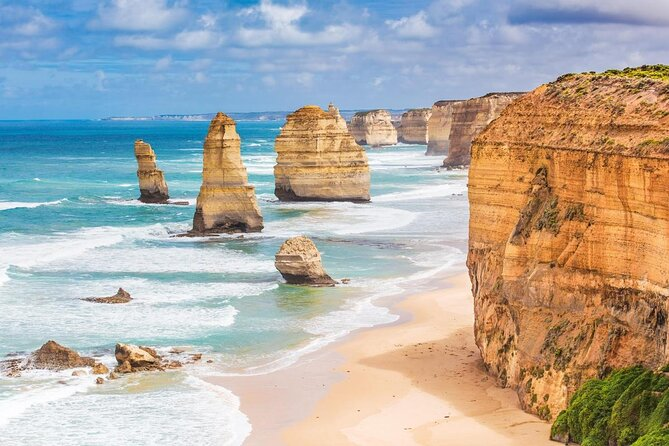What do you think is going on in this snapshot? This photograph illustrates the awe-inspiring view of the Twelve Apostles, a collection of limestone stacks along the Great Ocean Road in Victoria, Australia. These natural formations stand proudly against the vibrant blue ocean, their colors ranging from warm beige to deep orange. The shoreline features a sandy beach that runs along the base of soaring cliffs. The perspective from which this photo is taken offers a wide, panoramic view of the breathtaking scenery. Overhead, the sky is dotted with clouds, adding a sense of drama to the serene landscape. This image represents a harmonious blend of earth, sea, and sky, showcasing the untamed beauty of nature in its full glory. 